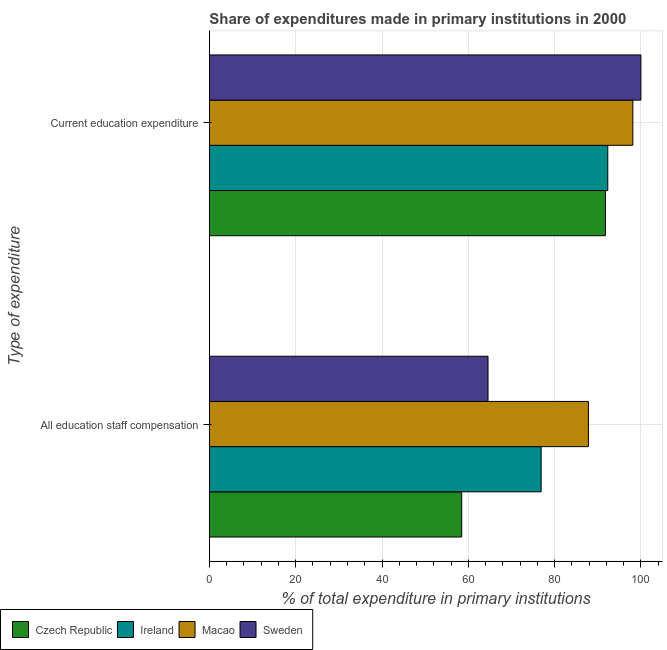How many different coloured bars are there?
Your answer should be compact. 4. How many groups of bars are there?
Offer a terse response. 2. How many bars are there on the 1st tick from the bottom?
Your answer should be compact. 4. What is the label of the 2nd group of bars from the top?
Give a very brief answer. All education staff compensation. What is the expenditure in staff compensation in Czech Republic?
Offer a terse response. 58.46. Across all countries, what is the minimum expenditure in staff compensation?
Offer a very short reply. 58.46. In which country was the expenditure in staff compensation maximum?
Your answer should be very brief. Macao. In which country was the expenditure in education minimum?
Your answer should be compact. Czech Republic. What is the total expenditure in staff compensation in the graph?
Keep it short and to the point. 287.74. What is the difference between the expenditure in education in Czech Republic and that in Sweden?
Ensure brevity in your answer.  -8.23. What is the difference between the expenditure in education in Czech Republic and the expenditure in staff compensation in Macao?
Your answer should be very brief. 3.94. What is the average expenditure in staff compensation per country?
Keep it short and to the point. 71.93. What is the difference between the expenditure in education and expenditure in staff compensation in Czech Republic?
Offer a very short reply. 33.31. What is the ratio of the expenditure in staff compensation in Ireland to that in Czech Republic?
Offer a terse response. 1.32. Is the expenditure in education in Czech Republic less than that in Macao?
Offer a terse response. Yes. In how many countries, is the expenditure in education greater than the average expenditure in education taken over all countries?
Provide a short and direct response. 2. What does the 4th bar from the top in Current education expenditure represents?
Make the answer very short. Czech Republic. What does the 3rd bar from the bottom in Current education expenditure represents?
Your answer should be compact. Macao. Are all the bars in the graph horizontal?
Offer a very short reply. Yes. Are the values on the major ticks of X-axis written in scientific E-notation?
Keep it short and to the point. No. Does the graph contain any zero values?
Ensure brevity in your answer.  No. Where does the legend appear in the graph?
Provide a short and direct response. Bottom left. How are the legend labels stacked?
Your answer should be compact. Horizontal. What is the title of the graph?
Ensure brevity in your answer.  Share of expenditures made in primary institutions in 2000. Does "Belize" appear as one of the legend labels in the graph?
Your answer should be very brief. No. What is the label or title of the X-axis?
Provide a short and direct response. % of total expenditure in primary institutions. What is the label or title of the Y-axis?
Provide a short and direct response. Type of expenditure. What is the % of total expenditure in primary institutions in Czech Republic in All education staff compensation?
Provide a succinct answer. 58.46. What is the % of total expenditure in primary institutions in Ireland in All education staff compensation?
Provide a short and direct response. 76.88. What is the % of total expenditure in primary institutions in Macao in All education staff compensation?
Offer a very short reply. 87.83. What is the % of total expenditure in primary institutions in Sweden in All education staff compensation?
Ensure brevity in your answer.  64.57. What is the % of total expenditure in primary institutions of Czech Republic in Current education expenditure?
Provide a short and direct response. 91.77. What is the % of total expenditure in primary institutions in Ireland in Current education expenditure?
Ensure brevity in your answer.  92.32. What is the % of total expenditure in primary institutions in Macao in Current education expenditure?
Provide a succinct answer. 98.13. What is the % of total expenditure in primary institutions of Sweden in Current education expenditure?
Your answer should be very brief. 100. Across all Type of expenditure, what is the maximum % of total expenditure in primary institutions in Czech Republic?
Make the answer very short. 91.77. Across all Type of expenditure, what is the maximum % of total expenditure in primary institutions in Ireland?
Give a very brief answer. 92.32. Across all Type of expenditure, what is the maximum % of total expenditure in primary institutions of Macao?
Offer a terse response. 98.13. Across all Type of expenditure, what is the maximum % of total expenditure in primary institutions of Sweden?
Offer a very short reply. 100. Across all Type of expenditure, what is the minimum % of total expenditure in primary institutions of Czech Republic?
Offer a terse response. 58.46. Across all Type of expenditure, what is the minimum % of total expenditure in primary institutions in Ireland?
Give a very brief answer. 76.88. Across all Type of expenditure, what is the minimum % of total expenditure in primary institutions in Macao?
Provide a short and direct response. 87.83. Across all Type of expenditure, what is the minimum % of total expenditure in primary institutions of Sweden?
Offer a very short reply. 64.57. What is the total % of total expenditure in primary institutions in Czech Republic in the graph?
Offer a very short reply. 150.23. What is the total % of total expenditure in primary institutions of Ireland in the graph?
Provide a short and direct response. 169.2. What is the total % of total expenditure in primary institutions of Macao in the graph?
Your answer should be compact. 185.96. What is the total % of total expenditure in primary institutions of Sweden in the graph?
Give a very brief answer. 164.57. What is the difference between the % of total expenditure in primary institutions of Czech Republic in All education staff compensation and that in Current education expenditure?
Provide a succinct answer. -33.31. What is the difference between the % of total expenditure in primary institutions in Ireland in All education staff compensation and that in Current education expenditure?
Provide a succinct answer. -15.45. What is the difference between the % of total expenditure in primary institutions in Macao in All education staff compensation and that in Current education expenditure?
Make the answer very short. -10.29. What is the difference between the % of total expenditure in primary institutions in Sweden in All education staff compensation and that in Current education expenditure?
Give a very brief answer. -35.43. What is the difference between the % of total expenditure in primary institutions in Czech Republic in All education staff compensation and the % of total expenditure in primary institutions in Ireland in Current education expenditure?
Your response must be concise. -33.86. What is the difference between the % of total expenditure in primary institutions in Czech Republic in All education staff compensation and the % of total expenditure in primary institutions in Macao in Current education expenditure?
Your response must be concise. -39.67. What is the difference between the % of total expenditure in primary institutions of Czech Republic in All education staff compensation and the % of total expenditure in primary institutions of Sweden in Current education expenditure?
Keep it short and to the point. -41.54. What is the difference between the % of total expenditure in primary institutions in Ireland in All education staff compensation and the % of total expenditure in primary institutions in Macao in Current education expenditure?
Your response must be concise. -21.25. What is the difference between the % of total expenditure in primary institutions of Ireland in All education staff compensation and the % of total expenditure in primary institutions of Sweden in Current education expenditure?
Your answer should be compact. -23.12. What is the difference between the % of total expenditure in primary institutions in Macao in All education staff compensation and the % of total expenditure in primary institutions in Sweden in Current education expenditure?
Give a very brief answer. -12.17. What is the average % of total expenditure in primary institutions of Czech Republic per Type of expenditure?
Make the answer very short. 75.12. What is the average % of total expenditure in primary institutions of Ireland per Type of expenditure?
Provide a short and direct response. 84.6. What is the average % of total expenditure in primary institutions of Macao per Type of expenditure?
Keep it short and to the point. 92.98. What is the average % of total expenditure in primary institutions of Sweden per Type of expenditure?
Offer a terse response. 82.28. What is the difference between the % of total expenditure in primary institutions of Czech Republic and % of total expenditure in primary institutions of Ireland in All education staff compensation?
Give a very brief answer. -18.42. What is the difference between the % of total expenditure in primary institutions of Czech Republic and % of total expenditure in primary institutions of Macao in All education staff compensation?
Offer a very short reply. -29.37. What is the difference between the % of total expenditure in primary institutions in Czech Republic and % of total expenditure in primary institutions in Sweden in All education staff compensation?
Your answer should be very brief. -6.11. What is the difference between the % of total expenditure in primary institutions of Ireland and % of total expenditure in primary institutions of Macao in All education staff compensation?
Ensure brevity in your answer.  -10.96. What is the difference between the % of total expenditure in primary institutions of Ireland and % of total expenditure in primary institutions of Sweden in All education staff compensation?
Provide a succinct answer. 12.31. What is the difference between the % of total expenditure in primary institutions of Macao and % of total expenditure in primary institutions of Sweden in All education staff compensation?
Your response must be concise. 23.27. What is the difference between the % of total expenditure in primary institutions in Czech Republic and % of total expenditure in primary institutions in Ireland in Current education expenditure?
Provide a succinct answer. -0.55. What is the difference between the % of total expenditure in primary institutions in Czech Republic and % of total expenditure in primary institutions in Macao in Current education expenditure?
Your response must be concise. -6.36. What is the difference between the % of total expenditure in primary institutions of Czech Republic and % of total expenditure in primary institutions of Sweden in Current education expenditure?
Provide a short and direct response. -8.23. What is the difference between the % of total expenditure in primary institutions in Ireland and % of total expenditure in primary institutions in Macao in Current education expenditure?
Keep it short and to the point. -5.81. What is the difference between the % of total expenditure in primary institutions in Ireland and % of total expenditure in primary institutions in Sweden in Current education expenditure?
Give a very brief answer. -7.68. What is the difference between the % of total expenditure in primary institutions in Macao and % of total expenditure in primary institutions in Sweden in Current education expenditure?
Give a very brief answer. -1.87. What is the ratio of the % of total expenditure in primary institutions in Czech Republic in All education staff compensation to that in Current education expenditure?
Your response must be concise. 0.64. What is the ratio of the % of total expenditure in primary institutions in Ireland in All education staff compensation to that in Current education expenditure?
Provide a succinct answer. 0.83. What is the ratio of the % of total expenditure in primary institutions of Macao in All education staff compensation to that in Current education expenditure?
Keep it short and to the point. 0.9. What is the ratio of the % of total expenditure in primary institutions of Sweden in All education staff compensation to that in Current education expenditure?
Provide a short and direct response. 0.65. What is the difference between the highest and the second highest % of total expenditure in primary institutions in Czech Republic?
Give a very brief answer. 33.31. What is the difference between the highest and the second highest % of total expenditure in primary institutions in Ireland?
Your response must be concise. 15.45. What is the difference between the highest and the second highest % of total expenditure in primary institutions in Macao?
Keep it short and to the point. 10.29. What is the difference between the highest and the second highest % of total expenditure in primary institutions in Sweden?
Provide a short and direct response. 35.43. What is the difference between the highest and the lowest % of total expenditure in primary institutions in Czech Republic?
Ensure brevity in your answer.  33.31. What is the difference between the highest and the lowest % of total expenditure in primary institutions in Ireland?
Keep it short and to the point. 15.45. What is the difference between the highest and the lowest % of total expenditure in primary institutions of Macao?
Keep it short and to the point. 10.29. What is the difference between the highest and the lowest % of total expenditure in primary institutions in Sweden?
Keep it short and to the point. 35.43. 